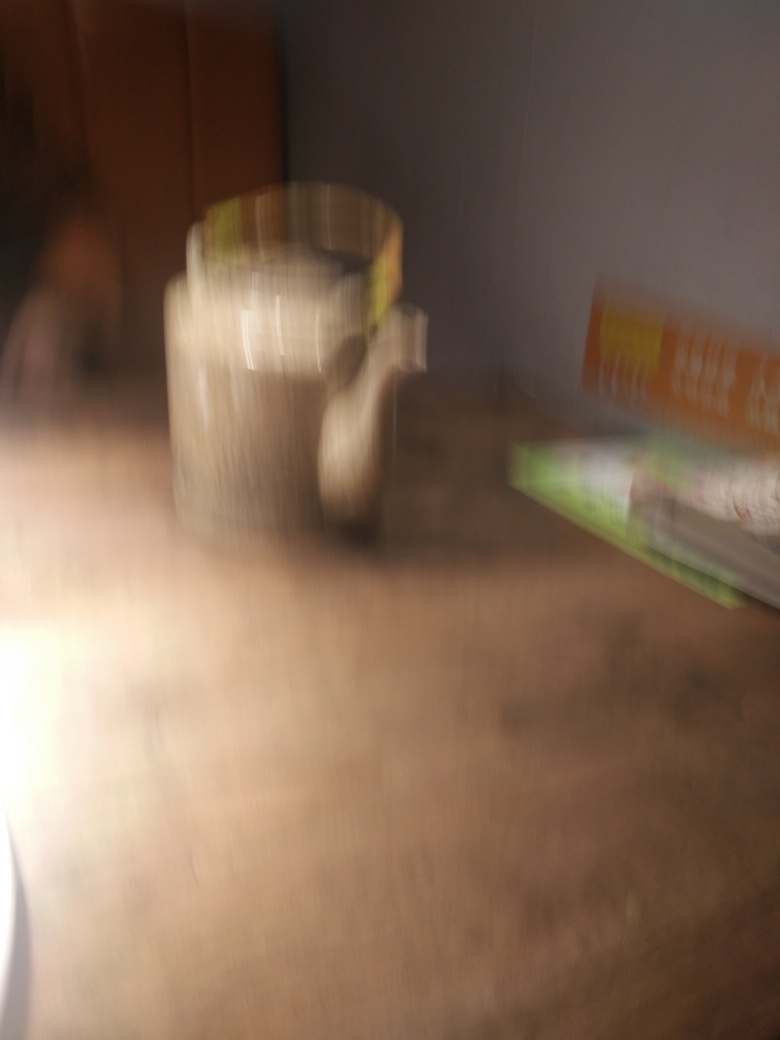Are there any discernible objects in the background despite the blur? Beyond the central blurred subject, there appears to be a flat surface, possibly a table, and what might be the edges of books or other rectangular objects towards the back. Due to the blurriness, it's difficult to identify them with precision, but they contribute to a sense of setting and context for the blurry subject in the center. 